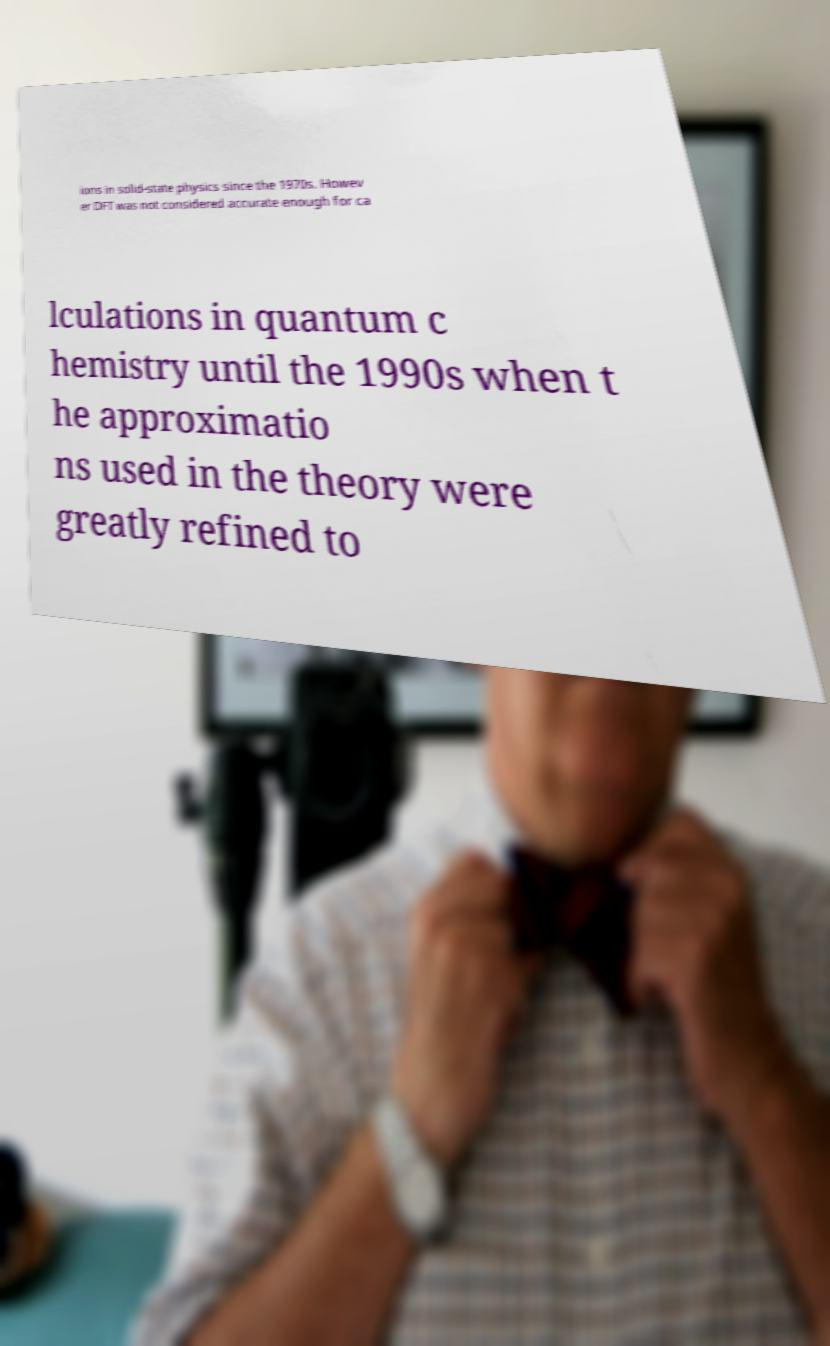Please read and relay the text visible in this image. What does it say? ions in solid-state physics since the 1970s. Howev er DFT was not considered accurate enough for ca lculations in quantum c hemistry until the 1990s when t he approximatio ns used in the theory were greatly refined to 